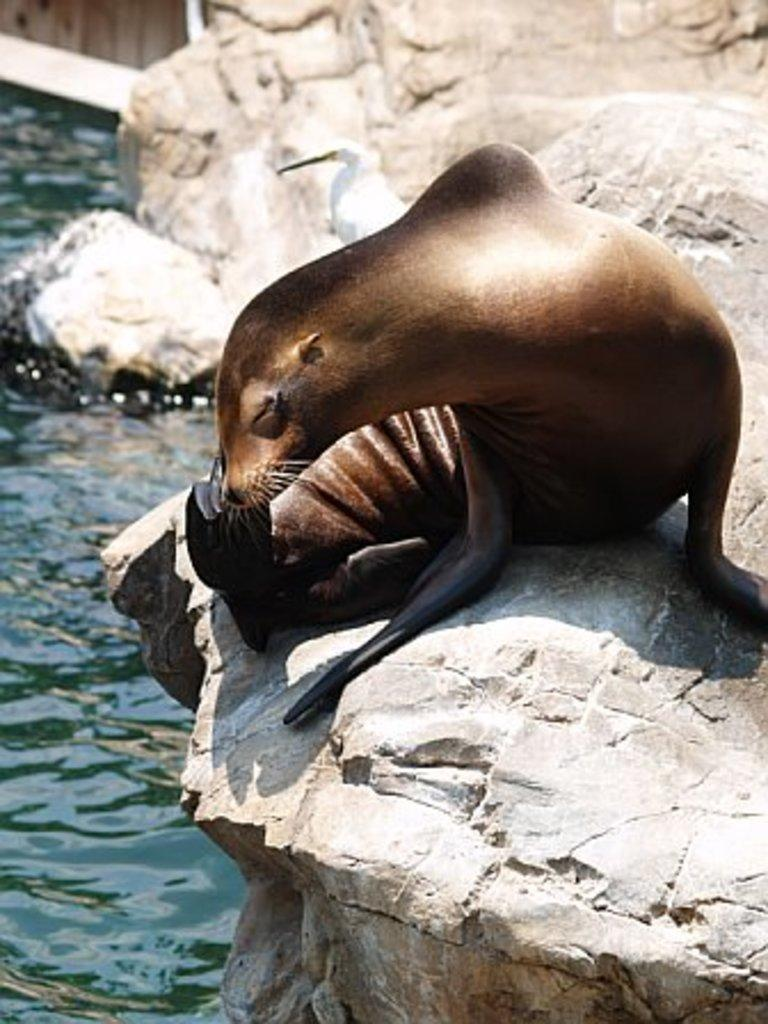What type of animal can be seen in the image? There is a sea lion visible on a rock in the image. Where is the sea lion located in the image? The sea lion is on the right side of the image. What is visible on the opposite side of the sea lion in the image? There is water visible on the left side of the image. Does the sea lion exhibit a tendency to experience pain in the image? There is no indication of pain or any emotional state in the image, as it is a photograph of a sea lion on a rock. 